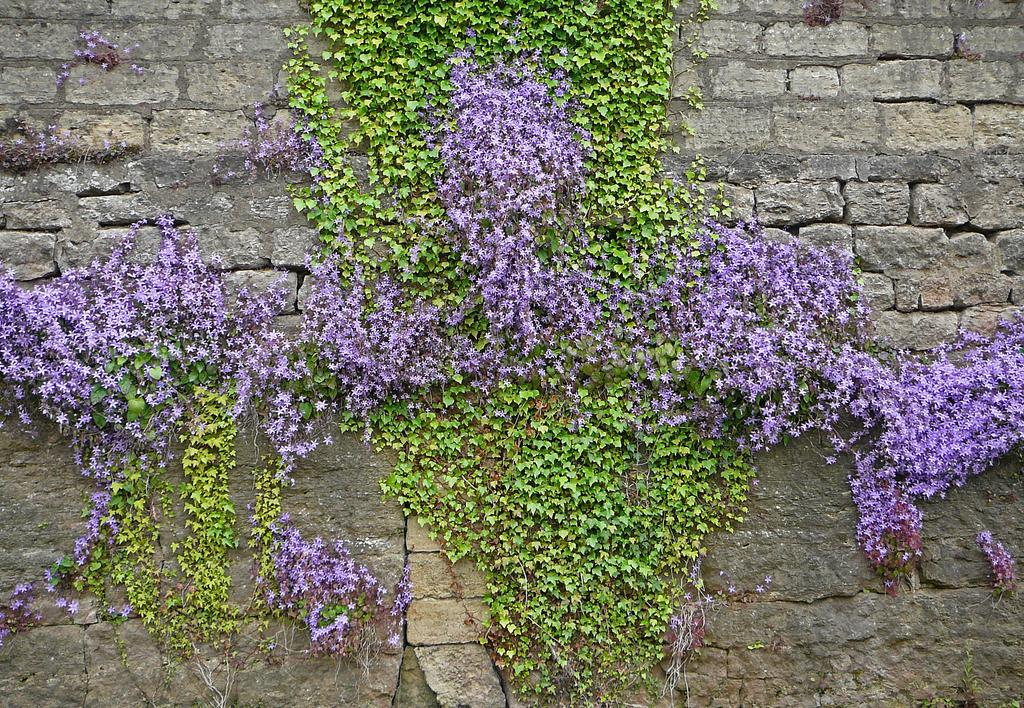What type of plants are in the image? There are wisteria plants in the image. Where are the wisteria plants located? The wisteria plants are on a stone wall. Can you see the plants smiling in the image? No, plants do not have the ability to smile, so it is not possible to see them smiling in the image. 